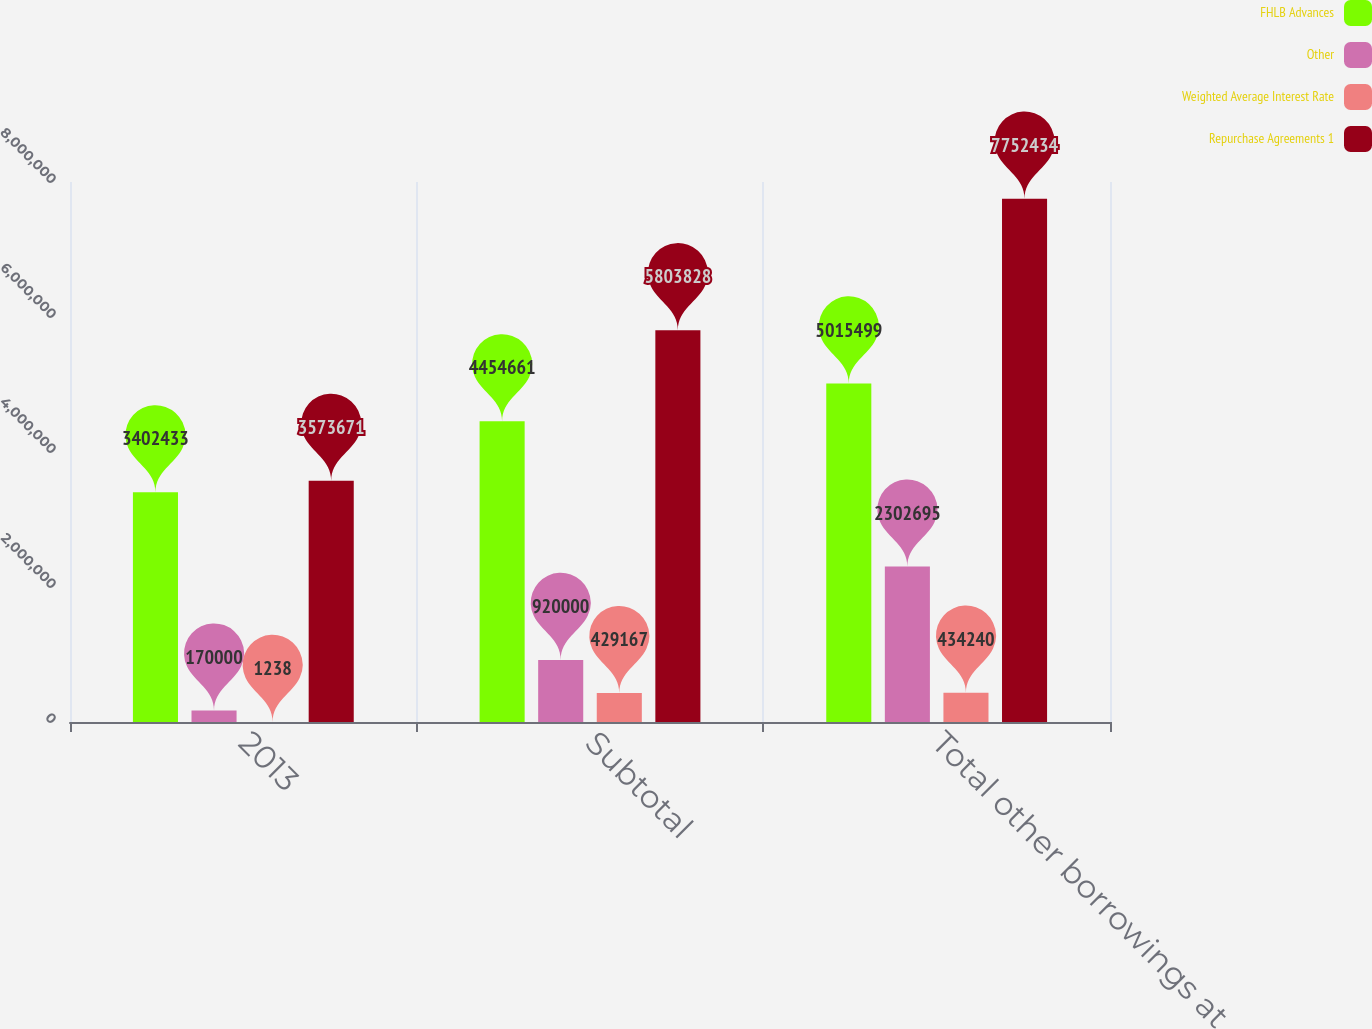<chart> <loc_0><loc_0><loc_500><loc_500><stacked_bar_chart><ecel><fcel>2013<fcel>Subtotal<fcel>Total other borrowings at<nl><fcel>FHLB Advances<fcel>3.40243e+06<fcel>4.45466e+06<fcel>5.0155e+06<nl><fcel>Other<fcel>170000<fcel>920000<fcel>2.3027e+06<nl><fcel>Weighted Average Interest Rate<fcel>1238<fcel>429167<fcel>434240<nl><fcel>Repurchase Agreements 1<fcel>3.57367e+06<fcel>5.80383e+06<fcel>7.75243e+06<nl></chart> 